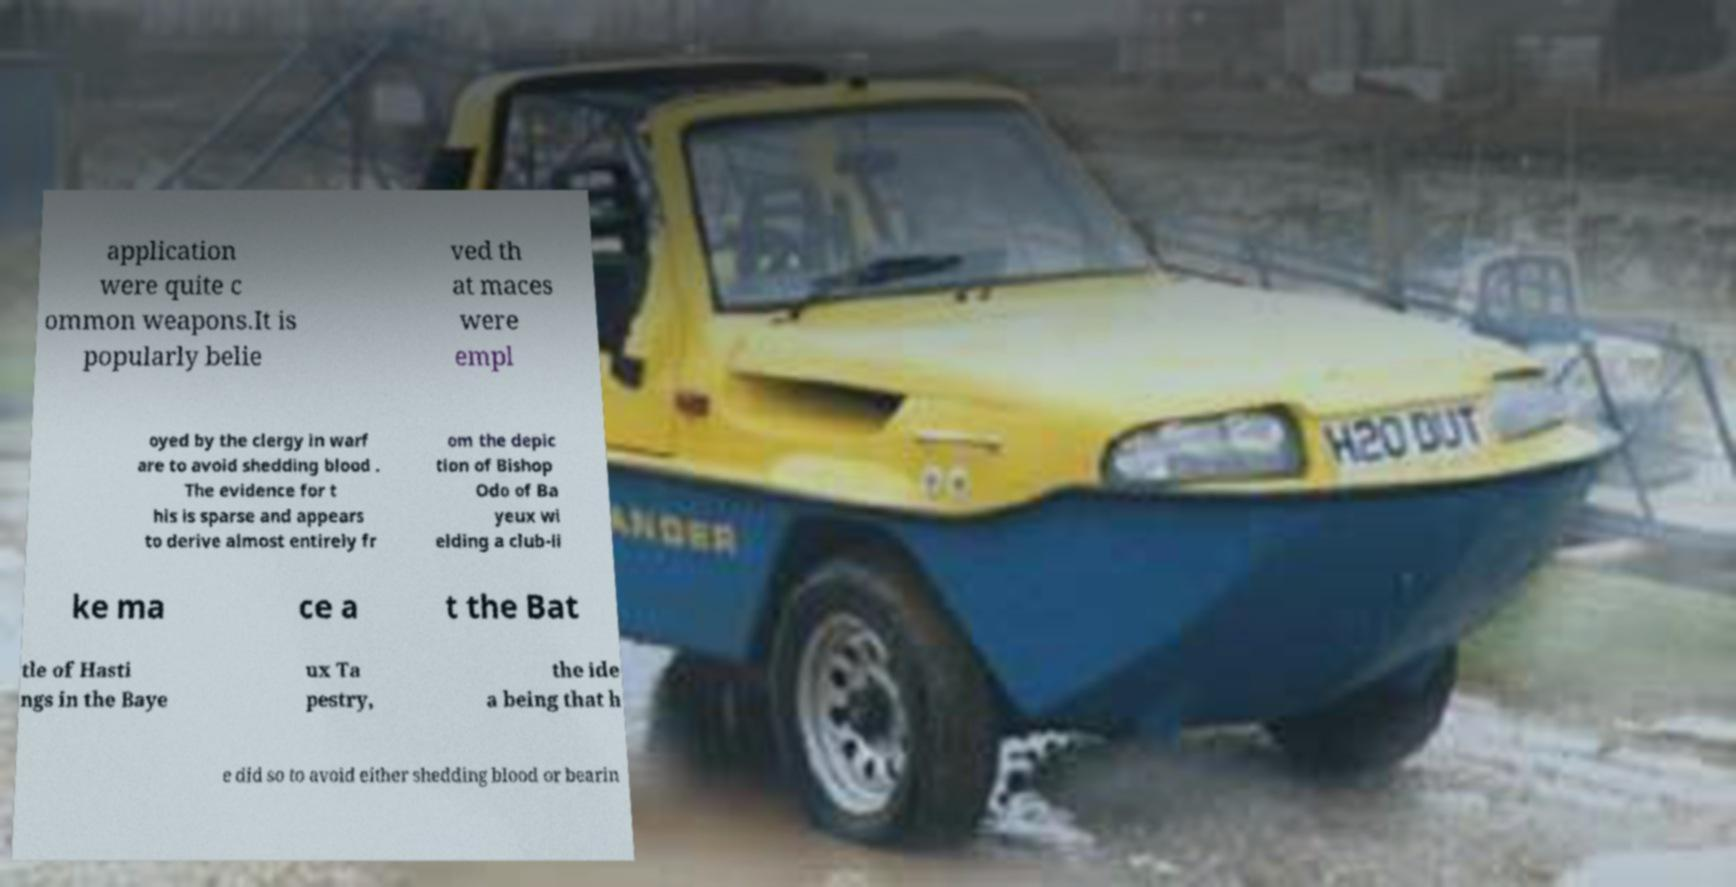Could you extract and type out the text from this image? application were quite c ommon weapons.It is popularly belie ved th at maces were empl oyed by the clergy in warf are to avoid shedding blood . The evidence for t his is sparse and appears to derive almost entirely fr om the depic tion of Bishop Odo of Ba yeux wi elding a club-li ke ma ce a t the Bat tle of Hasti ngs in the Baye ux Ta pestry, the ide a being that h e did so to avoid either shedding blood or bearin 